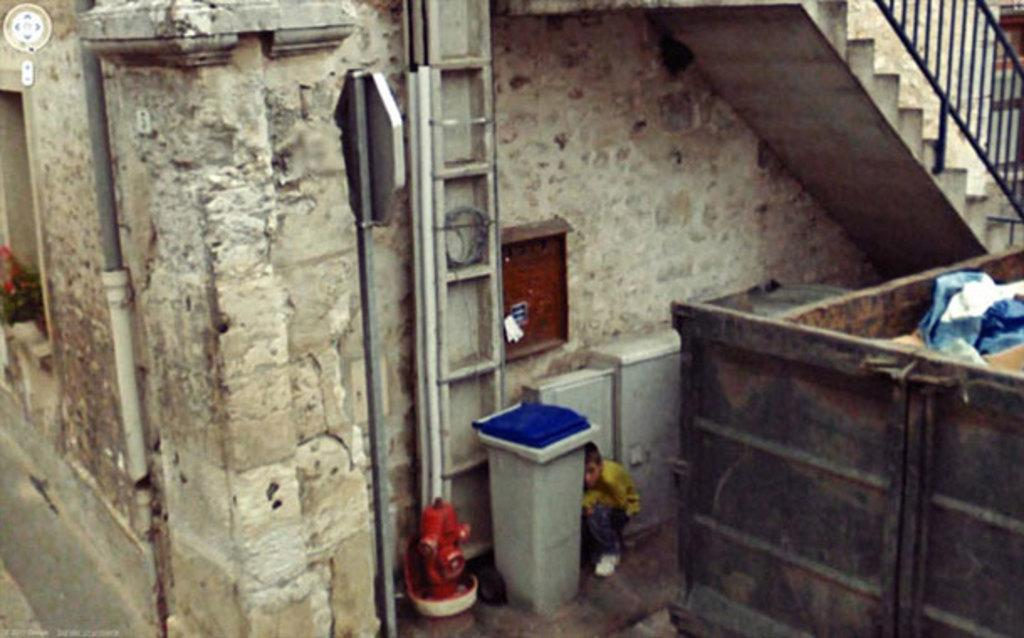What type of structure is present in the image? There is a building in the image. What celestial objects can be seen in the image? Stars are visible in the image. What object is attached to a pole in the image? There is a board attached to a pole in the image. Who is present in the image? There is a boy in the image. What type of ceremony is taking place at the cemetery in the image? There is no cemetery present in the image, and therefore no ceremony can be observed. What message does the minister deliver to the congregation in the image? There is no minister or congregation present in the image. 